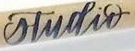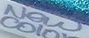What words can you see in these images in sequence, separated by a semicolon? studir; New 